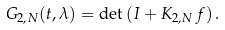Convert formula to latex. <formula><loc_0><loc_0><loc_500><loc_500>G _ { 2 , N } ( t , \lambda ) = \det \left ( I + K _ { 2 , N } \, f \right ) .</formula> 